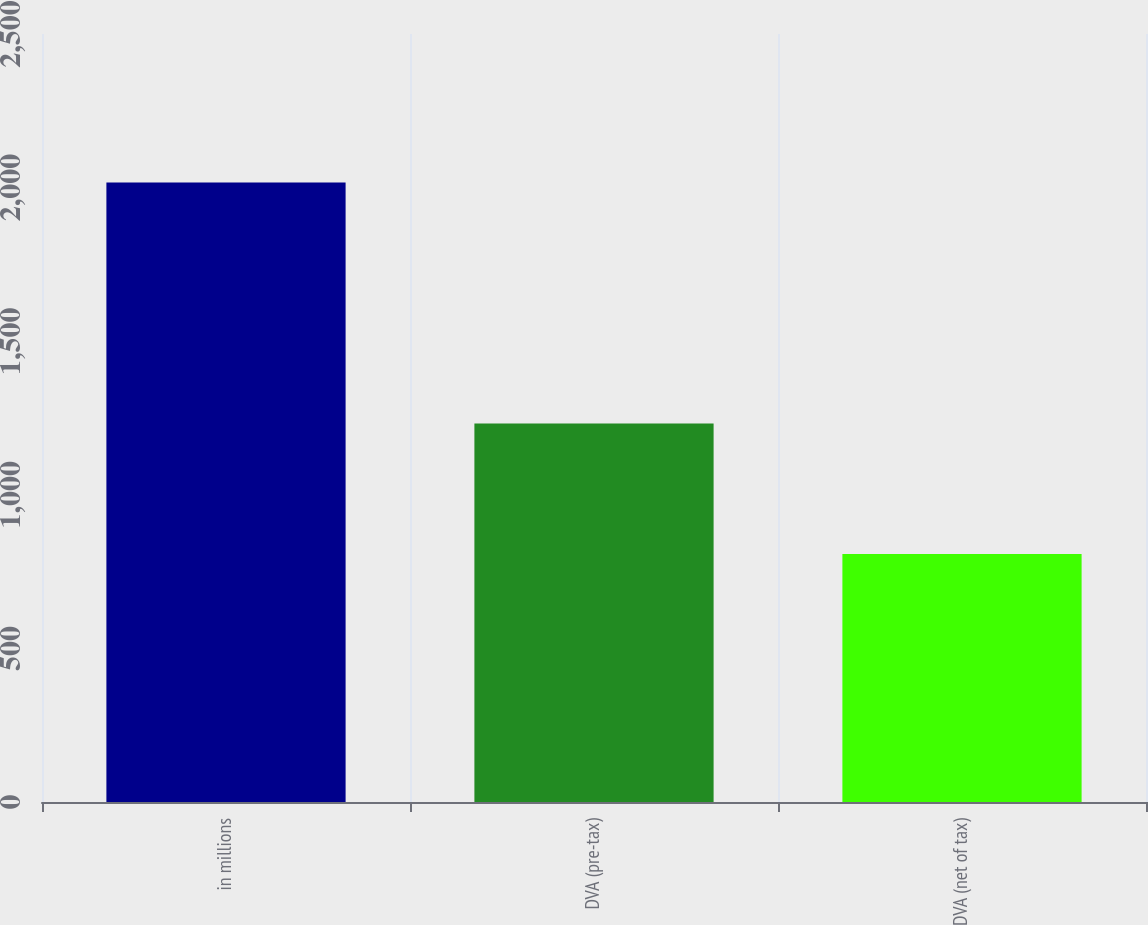Convert chart to OTSL. <chart><loc_0><loc_0><loc_500><loc_500><bar_chart><fcel>in millions<fcel>DVA (pre-tax)<fcel>DVA (net of tax)<nl><fcel>2017<fcel>1232<fcel>807<nl></chart> 